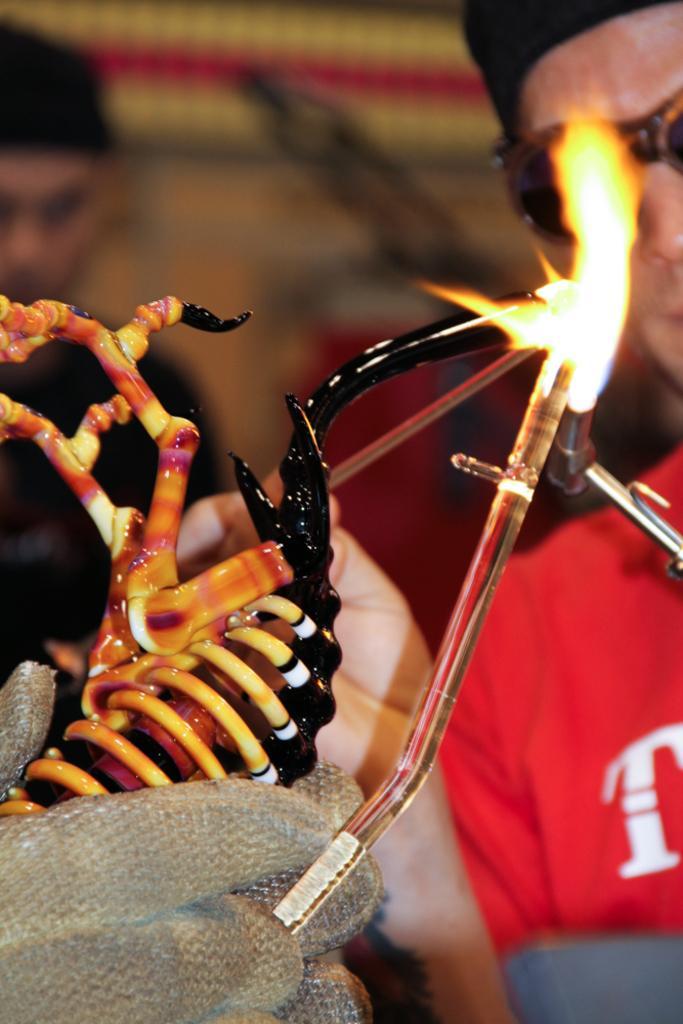How would you summarize this image in a sentence or two? In the bottom left corner of the image there are finger of person with gloves is holding an object. And also there is a glass tube and flame. Behind the flame there is a person with goggles. There is a blur background with a man. 